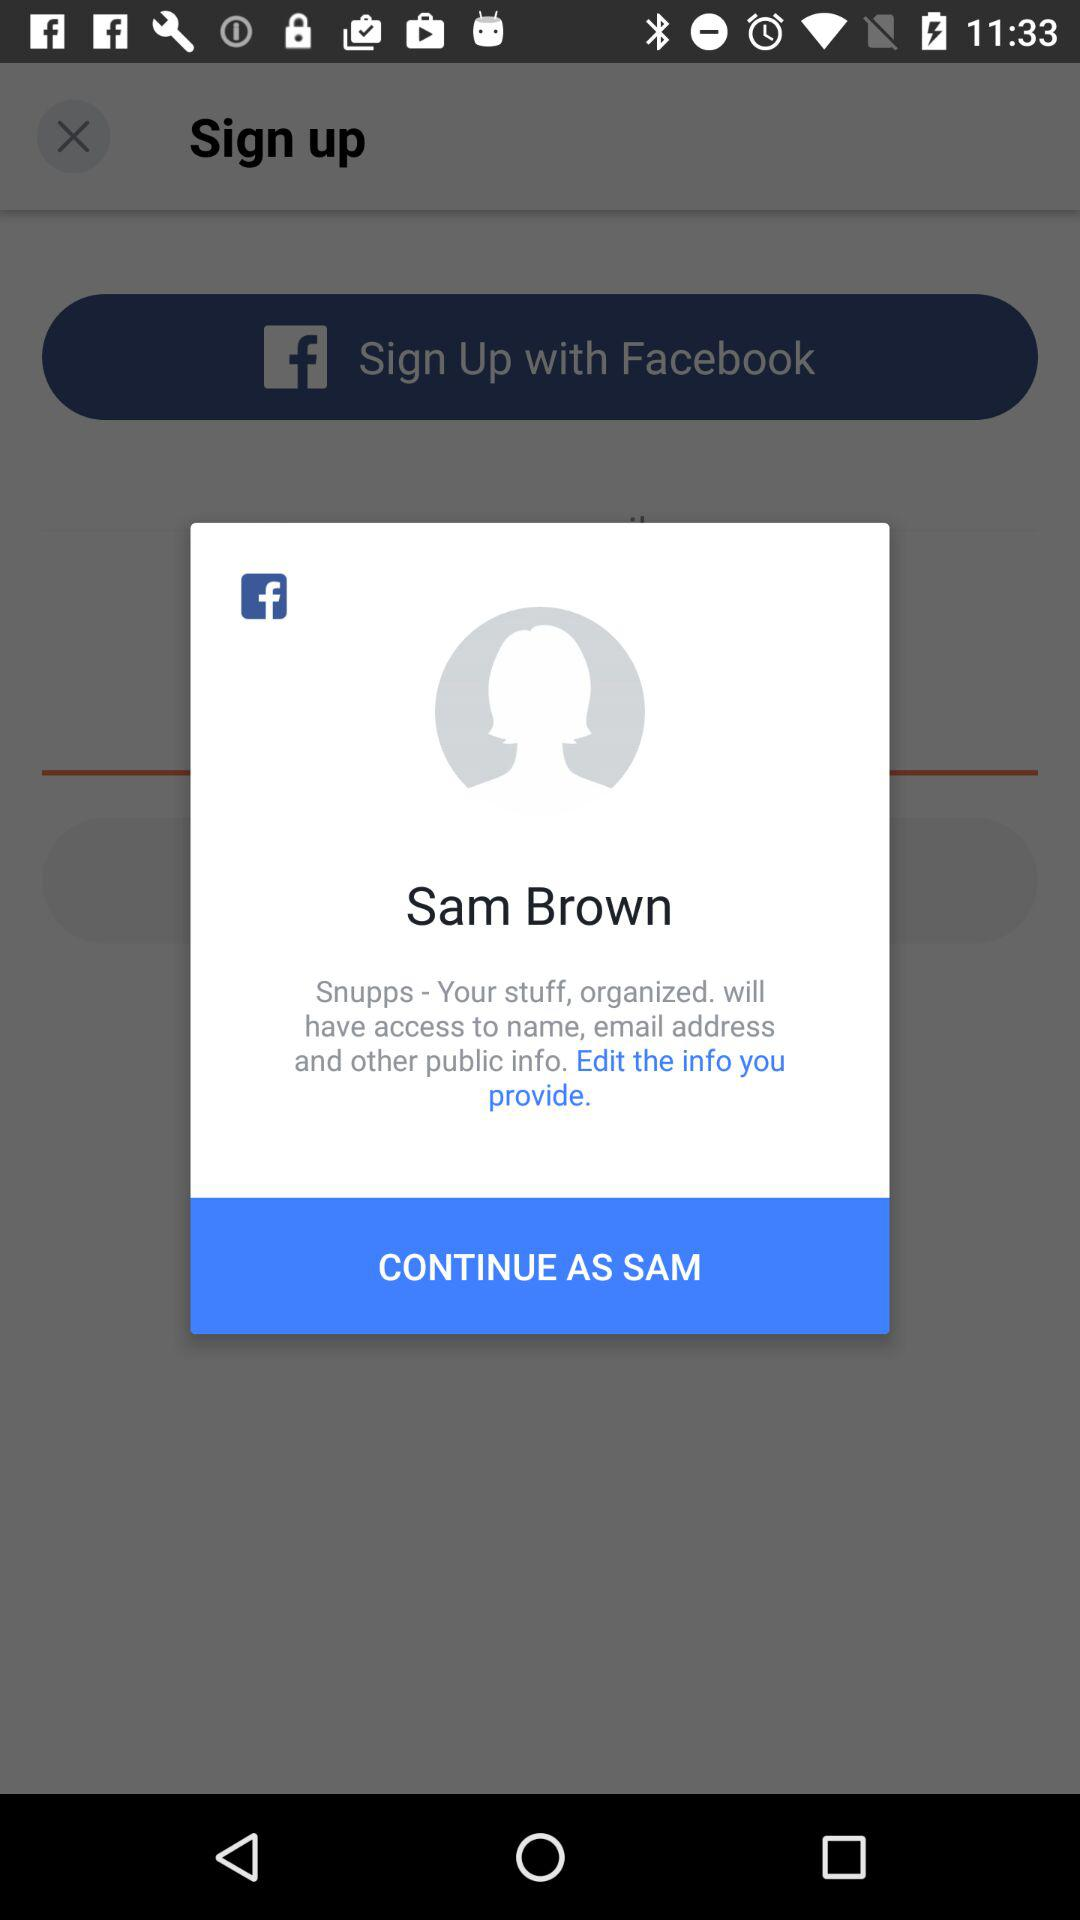Through what application can a user continue with? The user can continue with "Facebook". 